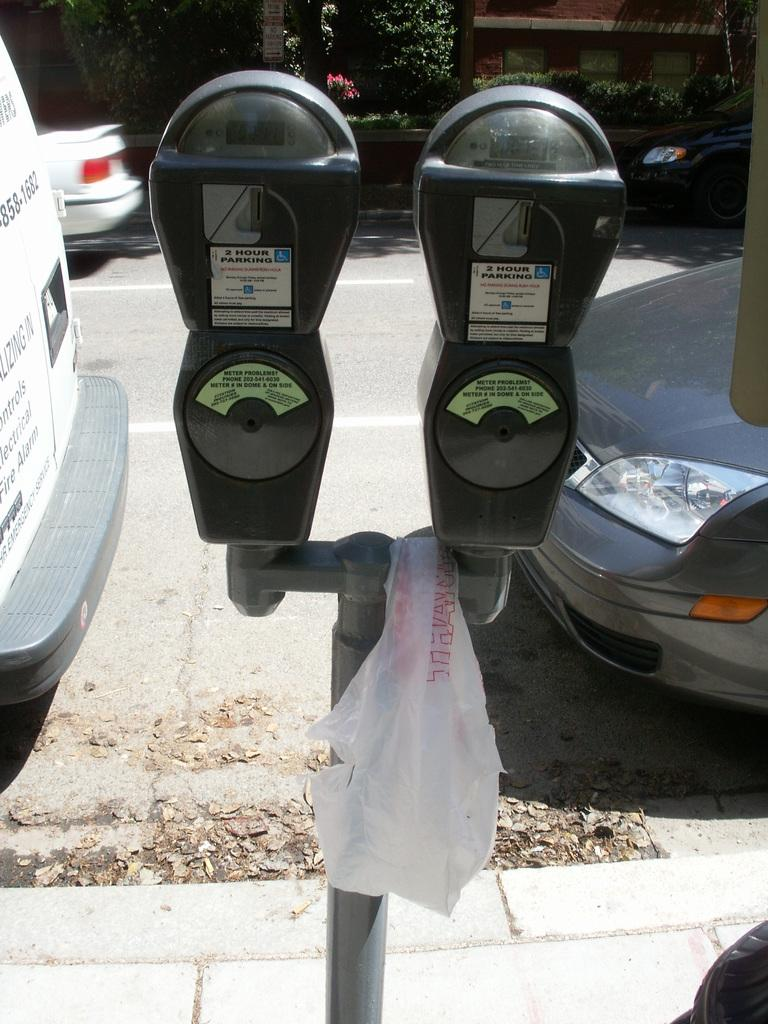<image>
Relay a brief, clear account of the picture shown. Two cars are parked beside two meters with timers 